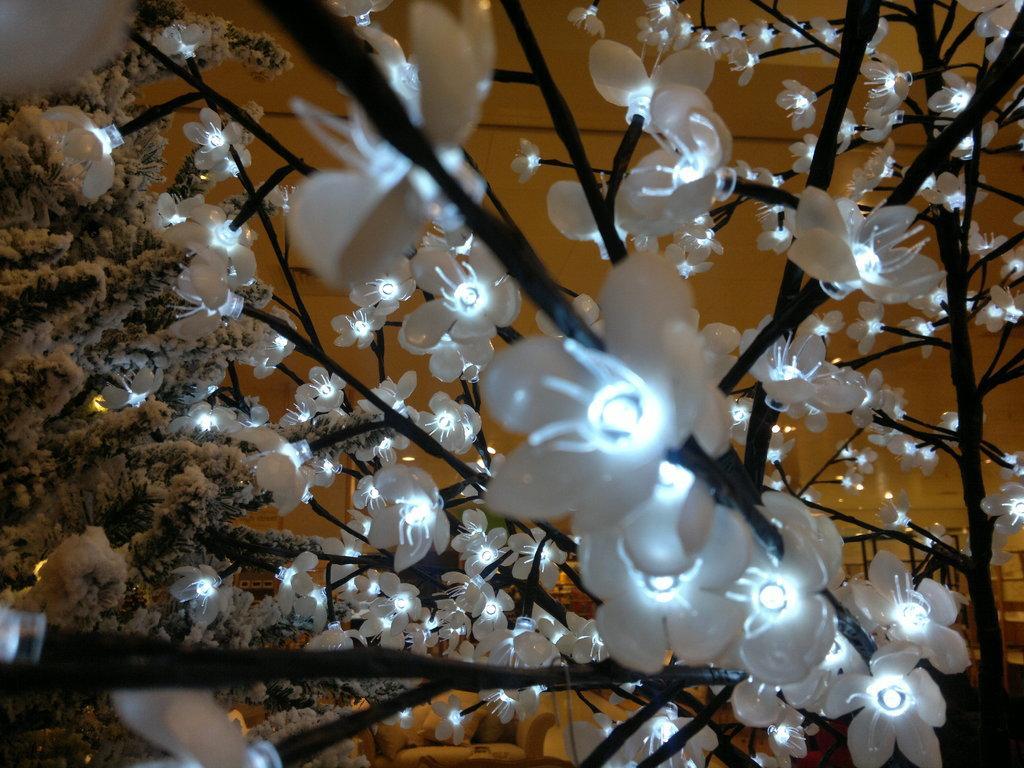Please provide a concise description of this image. In this image we can see there is a tree. On the tree there are some flower lights. 